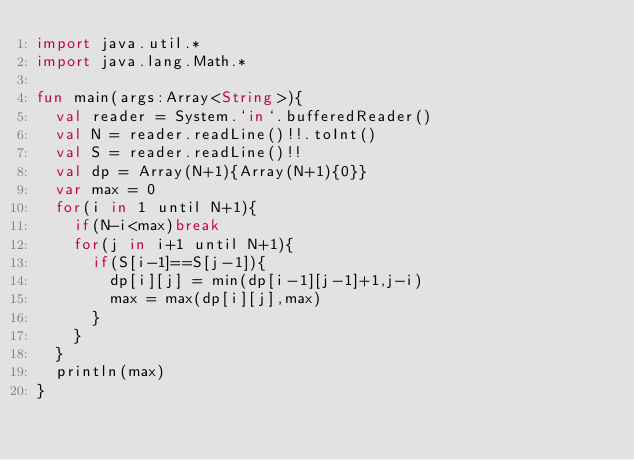Convert code to text. <code><loc_0><loc_0><loc_500><loc_500><_Kotlin_>import java.util.*
import java.lang.Math.*

fun main(args:Array<String>){
  val reader = System.`in`.bufferedReader()
  val N = reader.readLine()!!.toInt()
  val S = reader.readLine()!!
  val dp = Array(N+1){Array(N+1){0}}
  var max = 0
  for(i in 1 until N+1){
    if(N-i<max)break
    for(j in i+1 until N+1){
      if(S[i-1]==S[j-1]){
        dp[i][j] = min(dp[i-1][j-1]+1,j-i)
        max = max(dp[i][j],max)
      }
    }
  }
  println(max)
}

</code> 